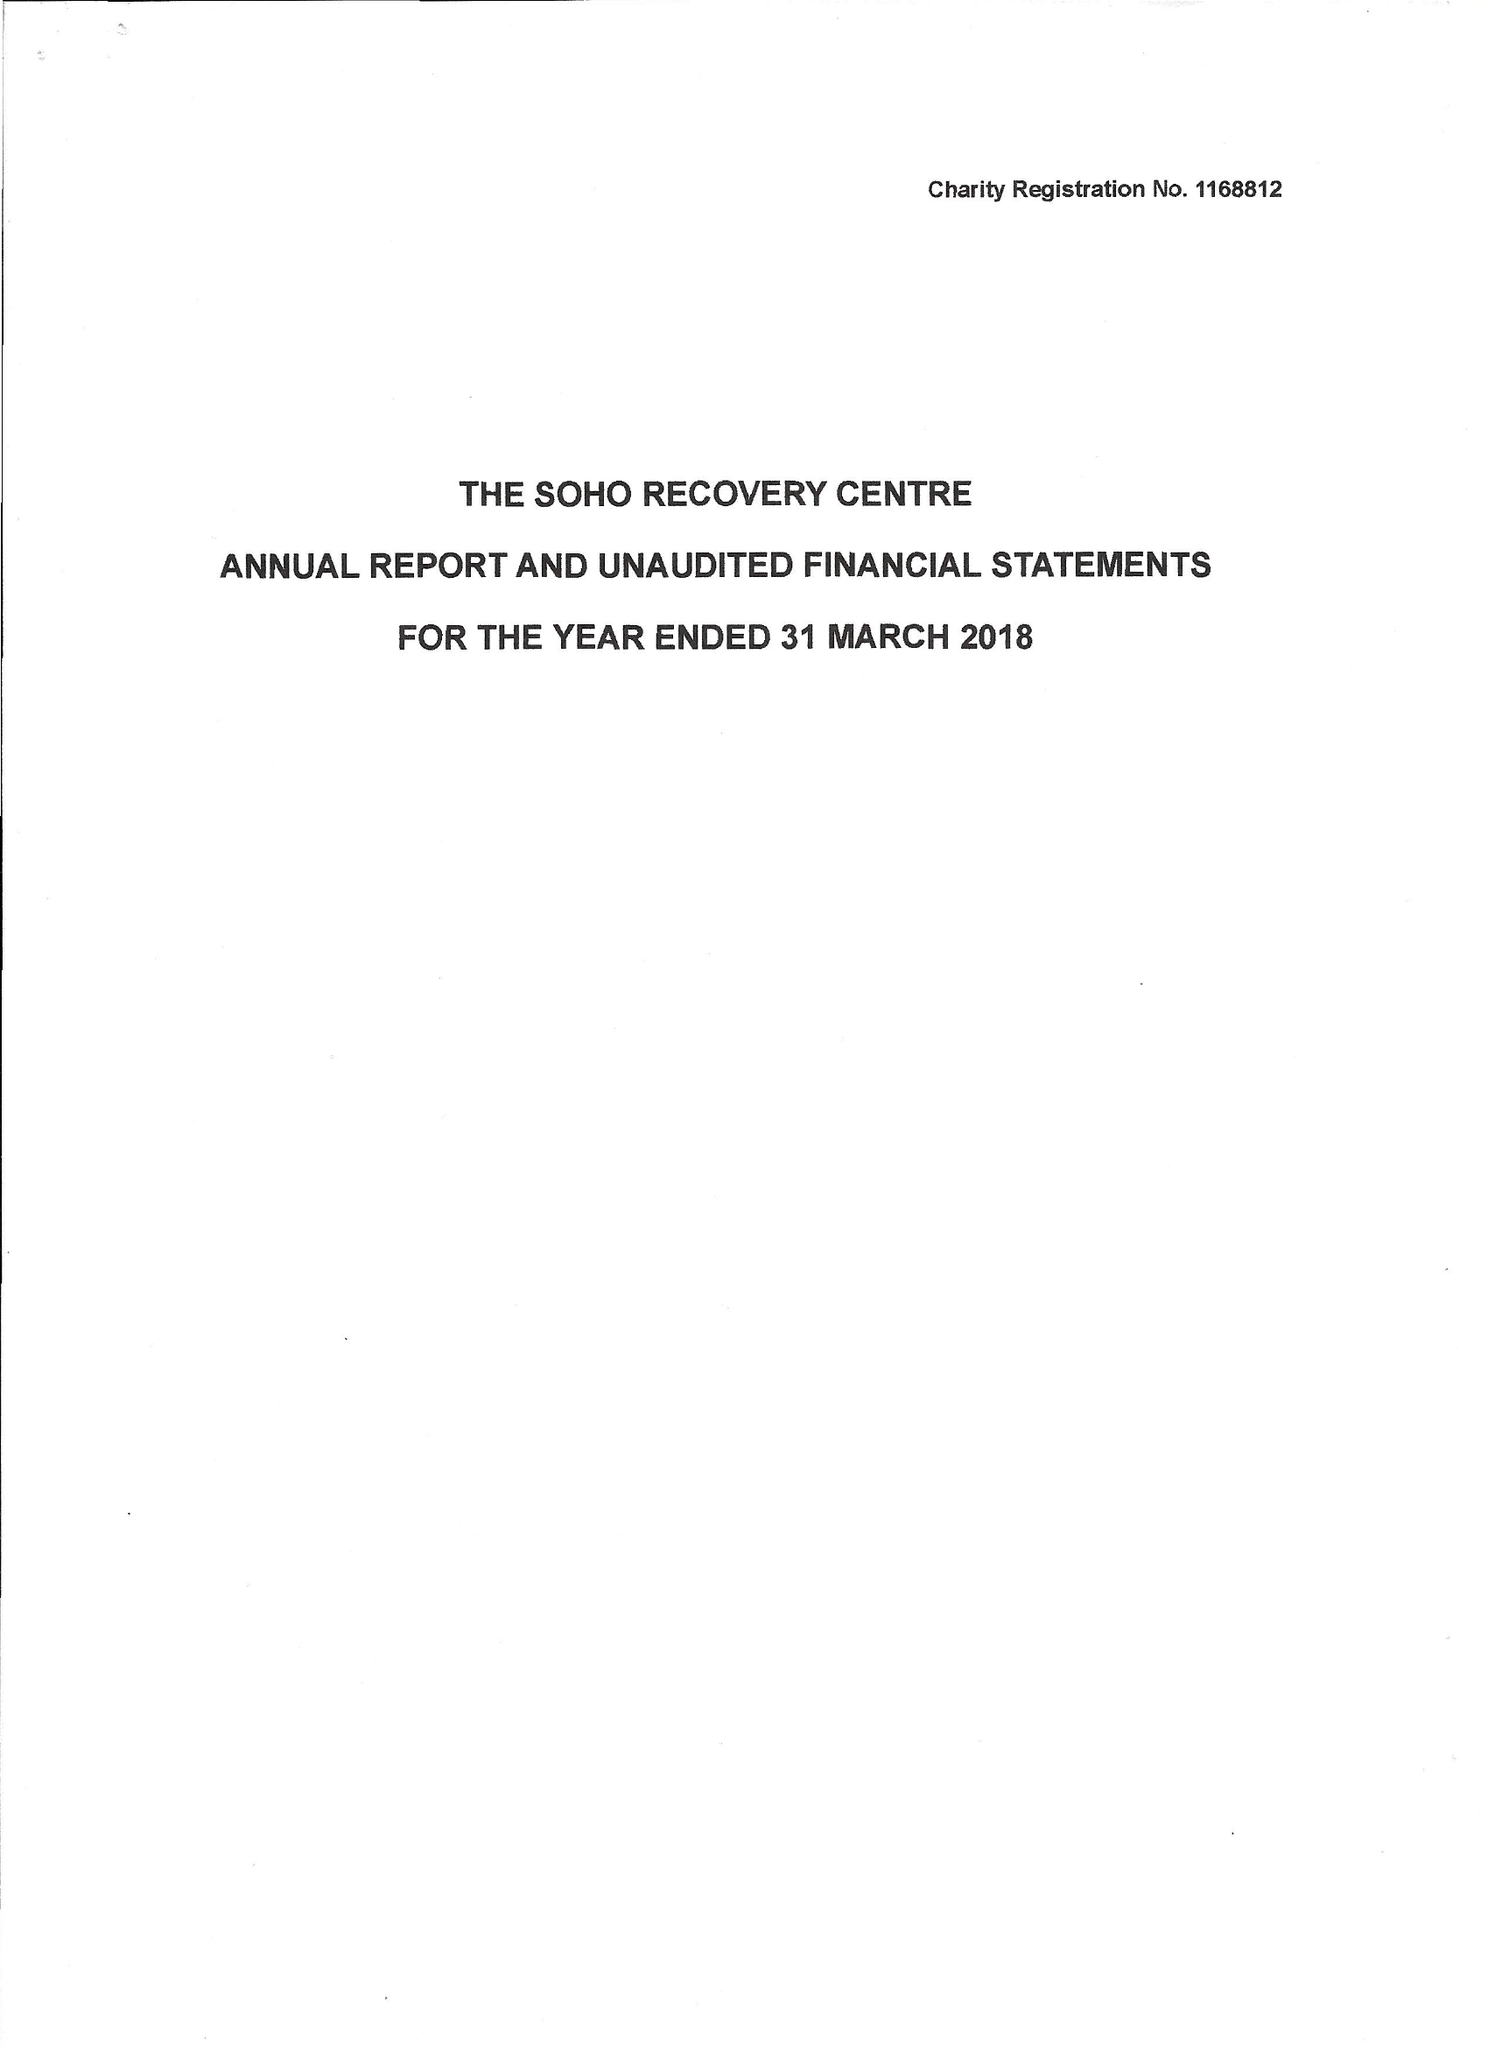What is the value for the charity_name?
Answer the question using a single word or phrase. The Soho Recovery Centre 